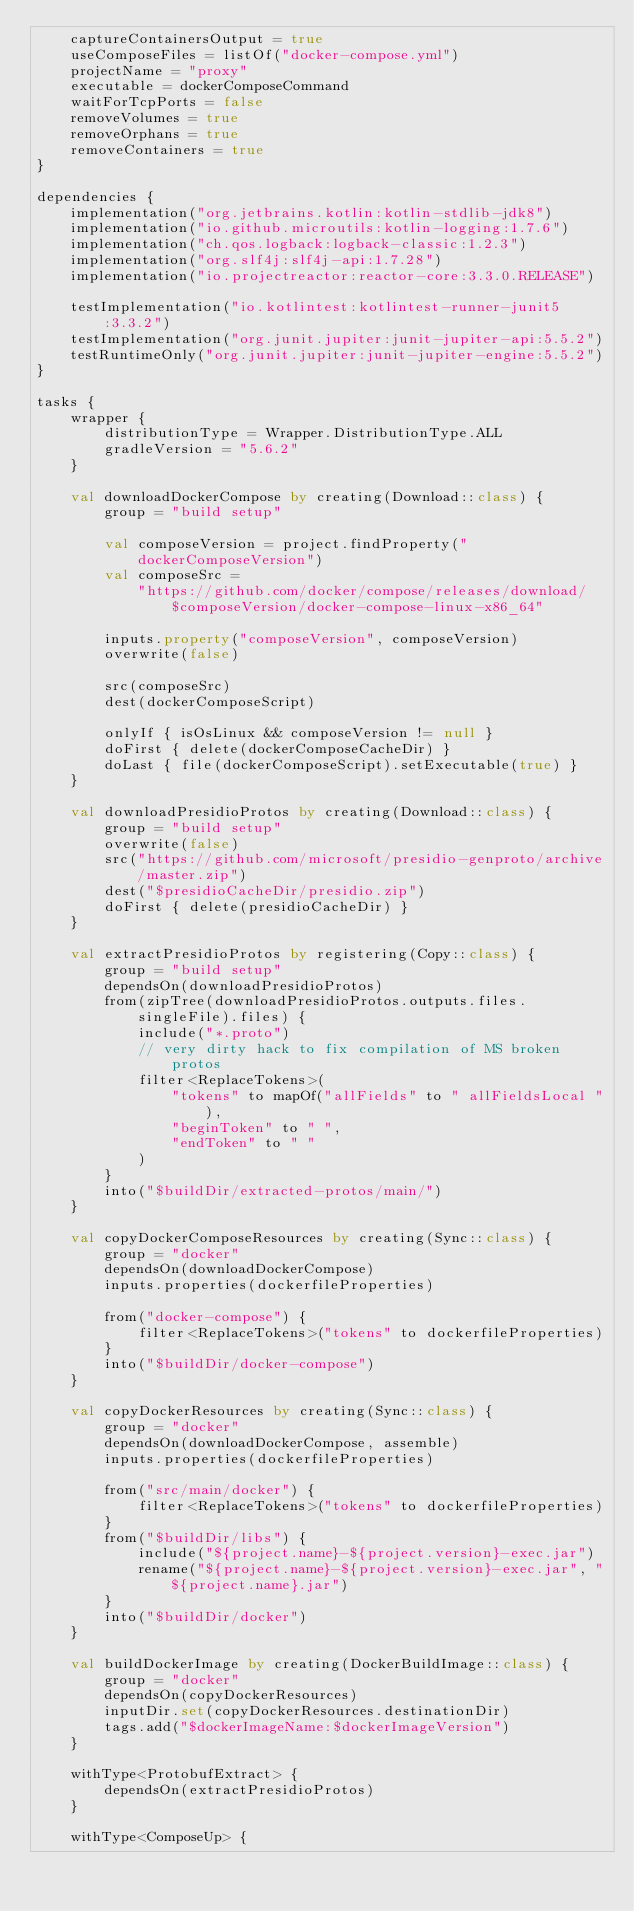Convert code to text. <code><loc_0><loc_0><loc_500><loc_500><_Kotlin_>    captureContainersOutput = true
    useComposeFiles = listOf("docker-compose.yml")
    projectName = "proxy"
    executable = dockerComposeCommand
    waitForTcpPorts = false
    removeVolumes = true
    removeOrphans = true
    removeContainers = true
}

dependencies {
    implementation("org.jetbrains.kotlin:kotlin-stdlib-jdk8")
    implementation("io.github.microutils:kotlin-logging:1.7.6")
    implementation("ch.qos.logback:logback-classic:1.2.3")
    implementation("org.slf4j:slf4j-api:1.7.28")
    implementation("io.projectreactor:reactor-core:3.3.0.RELEASE")

    testImplementation("io.kotlintest:kotlintest-runner-junit5:3.3.2")
    testImplementation("org.junit.jupiter:junit-jupiter-api:5.5.2")
    testRuntimeOnly("org.junit.jupiter:junit-jupiter-engine:5.5.2")
}

tasks {
    wrapper {
        distributionType = Wrapper.DistributionType.ALL
        gradleVersion = "5.6.2"
    }

    val downloadDockerCompose by creating(Download::class) {
        group = "build setup"

        val composeVersion = project.findProperty("dockerComposeVersion")
        val composeSrc =
            "https://github.com/docker/compose/releases/download/$composeVersion/docker-compose-linux-x86_64"

        inputs.property("composeVersion", composeVersion)
        overwrite(false)

        src(composeSrc)
        dest(dockerComposeScript)

        onlyIf { isOsLinux && composeVersion != null }
        doFirst { delete(dockerComposeCacheDir) }
        doLast { file(dockerComposeScript).setExecutable(true) }
    }

    val downloadPresidioProtos by creating(Download::class) {
        group = "build setup"
        overwrite(false)
        src("https://github.com/microsoft/presidio-genproto/archive/master.zip")
        dest("$presidioCacheDir/presidio.zip")
        doFirst { delete(presidioCacheDir) }
    }

    val extractPresidioProtos by registering(Copy::class) {
        group = "build setup"
        dependsOn(downloadPresidioProtos)
        from(zipTree(downloadPresidioProtos.outputs.files.singleFile).files) {
            include("*.proto")
            // very dirty hack to fix compilation of MS broken protos
            filter<ReplaceTokens>(
                "tokens" to mapOf("allFields" to " allFieldsLocal "),
                "beginToken" to " ",
                "endToken" to " "
            )
        }
        into("$buildDir/extracted-protos/main/")
    }

    val copyDockerComposeResources by creating(Sync::class) {
        group = "docker"
        dependsOn(downloadDockerCompose)
        inputs.properties(dockerfileProperties)

        from("docker-compose") {
            filter<ReplaceTokens>("tokens" to dockerfileProperties)
        }
        into("$buildDir/docker-compose")
    }

    val copyDockerResources by creating(Sync::class) {
        group = "docker"
        dependsOn(downloadDockerCompose, assemble)
        inputs.properties(dockerfileProperties)

        from("src/main/docker") {
            filter<ReplaceTokens>("tokens" to dockerfileProperties)
        }
        from("$buildDir/libs") {
            include("${project.name}-${project.version}-exec.jar")
            rename("${project.name}-${project.version}-exec.jar", "${project.name}.jar")
        }
        into("$buildDir/docker")
    }

    val buildDockerImage by creating(DockerBuildImage::class) {
        group = "docker"
        dependsOn(copyDockerResources)
        inputDir.set(copyDockerResources.destinationDir)
        tags.add("$dockerImageName:$dockerImageVersion")
    }

    withType<ProtobufExtract> {
        dependsOn(extractPresidioProtos)
    }

    withType<ComposeUp> {</code> 